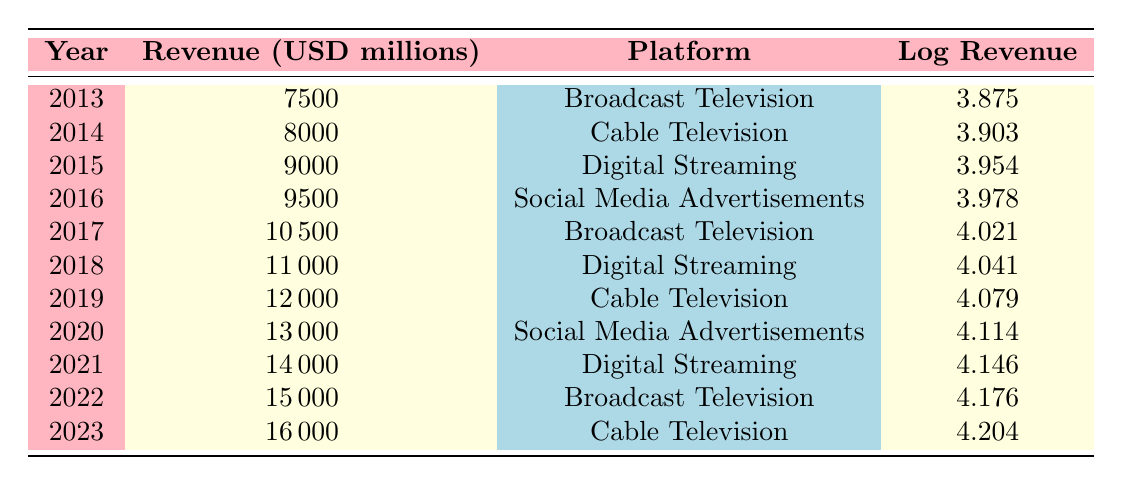What was the revenue for Broadcast Television in 2017? The table shows that in 2017, the revenue for Broadcast Television was 10,500 million USD.
Answer: 10,500 million USD In which year did Digital Streaming first exceed 10,000 million USD in revenue? By looking at the table, Digital Streaming first exceeded 10,000 million USD in 2018 with a revenue of 11,000 million USD.
Answer: 2018 What is the total revenue for Cable Television over the entire decade? The revenue for Cable Television can be summed from the years 2014, 2019, and 2023: 8,000 + 12,000 + 16,000 = 36,000 million USD.
Answer: 36,000 million USD Was there any year where Social Media Advertisements had a higher revenue than Digital Streaming? By comparing the revenues of the two platforms, Social Media Advertisements had higher revenue than Digital Streaming only in 2016 (9,500 million USD vs. 9,000 million USD in 2015). Therefore, the answer is true for that specific year only.
Answer: Yes What is the average revenue across all platforms in the year 2020? In 2020, the revenue for Social Media Advertisements was 13,000 million USD. Given that there is only one platform reported for this year, the average revenue is also 13,000 million USD.
Answer: 13,000 million USD How much did revenue increase from 2015 to 2021? The revenue in 2015 was 9,000 million USD, and in 2021 it was 14,000 million USD. To find the increase: 14,000 - 9,000 = 5,000 million USD.
Answer: 5,000 million USD Which platform had the highest revenue in 2022? The table indicates that in 2022, Broadcast Television had the highest revenue of 15,000 million USD for that year.
Answer: Broadcast Television In which year did the total revenue between Digital Streaming and Social Media Advertisements reach 25,000 million USD for the first time? To find when their combined revenue first reached 25,000 million USD, total revenue must be calculated for both platforms over the years. In 2018, Digital Streaming (11,000 million) + Social Media Advertisements (0) = 11,000 million. By 2021, it reached 14,000 million (Digital Streaming) + 13,000 million (Social Media Advertisements) = 27,000 million. Therefore, the first year is 2020 when it combined reached 25,000 million (13,000 for Social Media).
Answer: 2020 